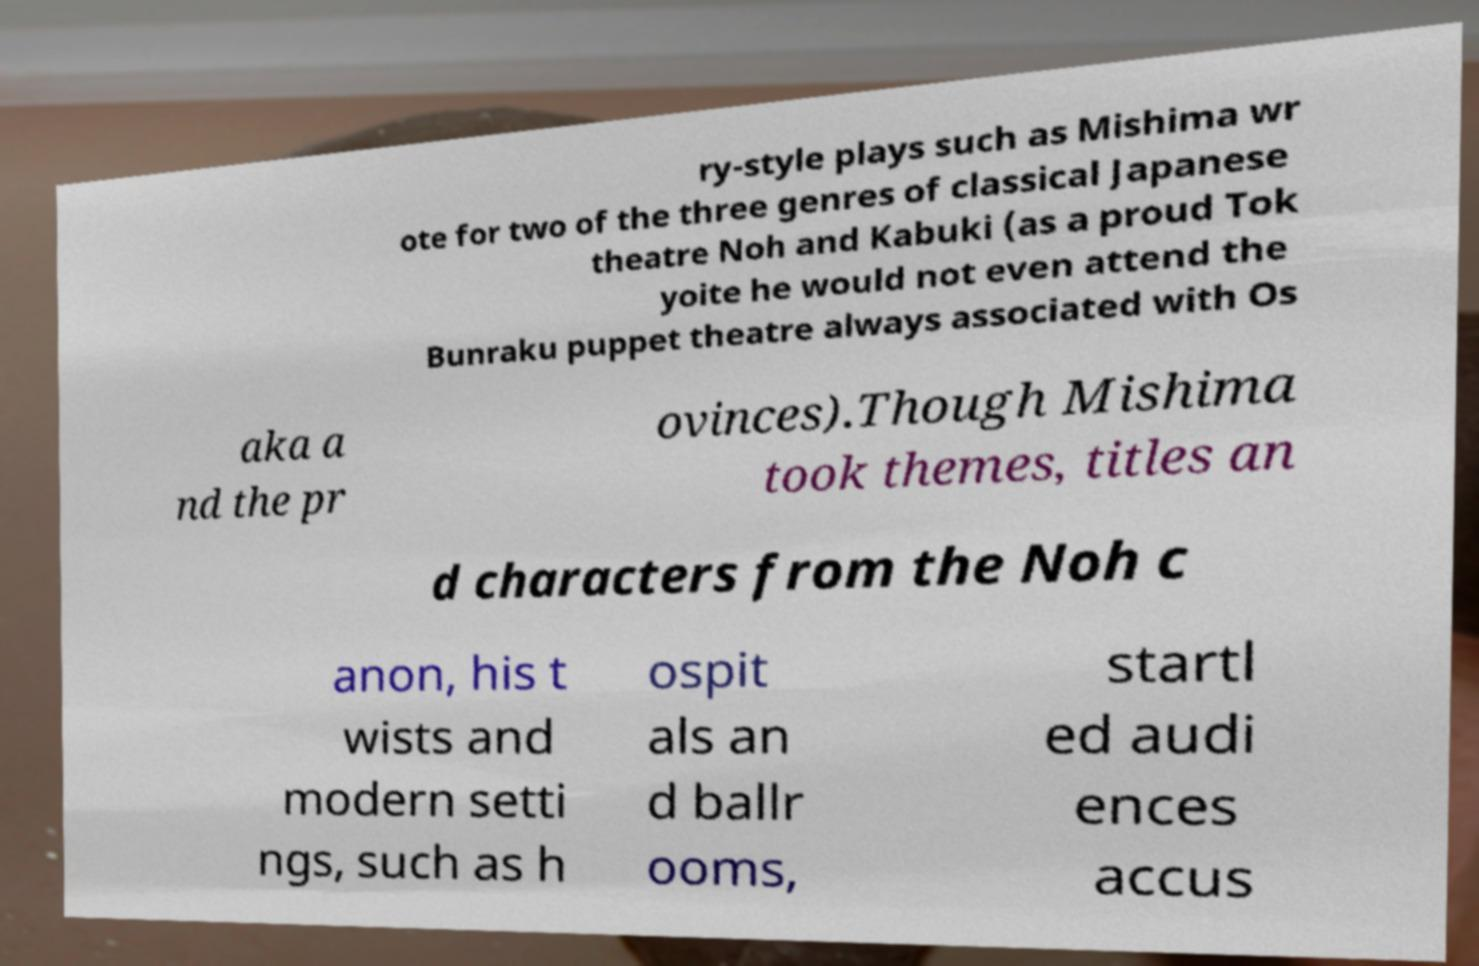For documentation purposes, I need the text within this image transcribed. Could you provide that? ry-style plays such as Mishima wr ote for two of the three genres of classical Japanese theatre Noh and Kabuki (as a proud Tok yoite he would not even attend the Bunraku puppet theatre always associated with Os aka a nd the pr ovinces).Though Mishima took themes, titles an d characters from the Noh c anon, his t wists and modern setti ngs, such as h ospit als an d ballr ooms, startl ed audi ences accus 